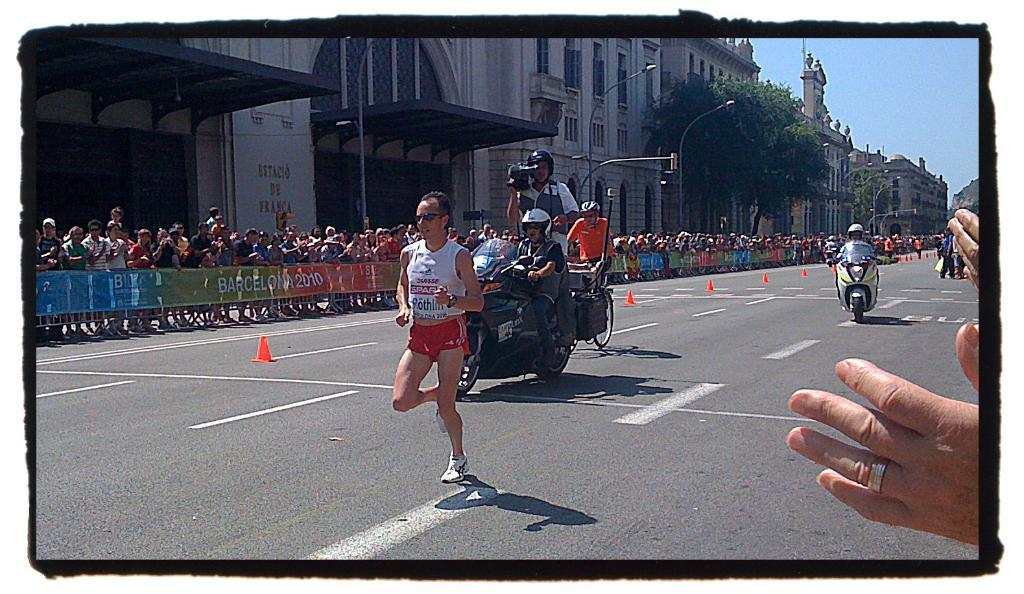What is the main action of the person in the image? There is a person running on the road in the image. Are there any other people involved in the scene? Yes, there are people riding bikes behind the running person. What can be seen beside the road? There is a fence beside the road. What type of structures are visible in the image? There are buildings visible in the image. What type of vegetation is present in the image? Trees are present in the image. What else can be seen in the image? Poles are visible in the image. What type of slave is depicted in the image? There is no depiction of a slave in the image; it features a person running and people riding bikes. What is the route the person is running on in the image? The image does not provide information about the specific route the person is running on; it only shows the person running on a road. 